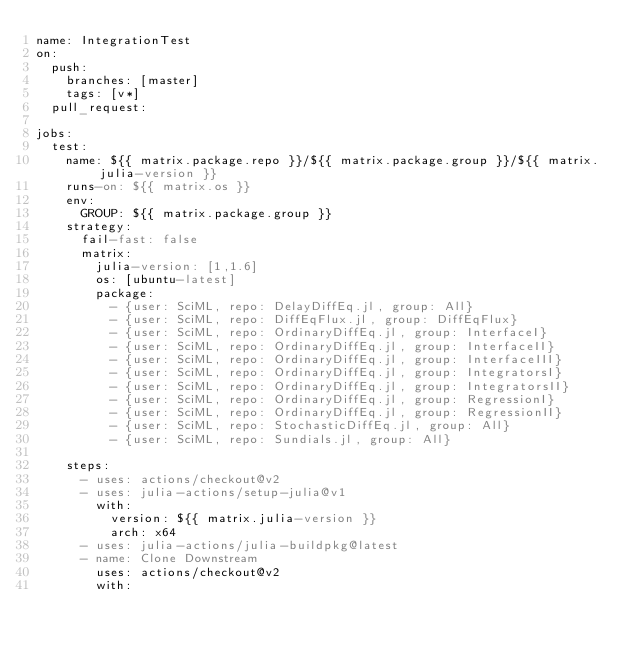Convert code to text. <code><loc_0><loc_0><loc_500><loc_500><_YAML_>name: IntegrationTest
on:
  push:
    branches: [master]
    tags: [v*]
  pull_request:

jobs:
  test:
    name: ${{ matrix.package.repo }}/${{ matrix.package.group }}/${{ matrix.julia-version }}
    runs-on: ${{ matrix.os }}
    env:
      GROUP: ${{ matrix.package.group }}
    strategy:
      fail-fast: false
      matrix:
        julia-version: [1,1.6]
        os: [ubuntu-latest]
        package:
          - {user: SciML, repo: DelayDiffEq.jl, group: All}
          - {user: SciML, repo: DiffEqFlux.jl, group: DiffEqFlux}
          - {user: SciML, repo: OrdinaryDiffEq.jl, group: InterfaceI}
          - {user: SciML, repo: OrdinaryDiffEq.jl, group: InterfaceII}
          - {user: SciML, repo: OrdinaryDiffEq.jl, group: InterfaceIII}
          - {user: SciML, repo: OrdinaryDiffEq.jl, group: IntegratorsI}
          - {user: SciML, repo: OrdinaryDiffEq.jl, group: IntegratorsII}
          - {user: SciML, repo: OrdinaryDiffEq.jl, group: RegressionI}
          - {user: SciML, repo: OrdinaryDiffEq.jl, group: RegressionII}
          - {user: SciML, repo: StochasticDiffEq.jl, group: All}
          - {user: SciML, repo: Sundials.jl, group: All}

    steps:
      - uses: actions/checkout@v2
      - uses: julia-actions/setup-julia@v1
        with:
          version: ${{ matrix.julia-version }}
          arch: x64
      - uses: julia-actions/julia-buildpkg@latest
      - name: Clone Downstream
        uses: actions/checkout@v2
        with:</code> 